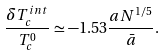Convert formula to latex. <formula><loc_0><loc_0><loc_500><loc_500>\frac { \delta T _ { c } ^ { i n t } } { T _ { c } ^ { 0 } } \simeq - 1 . 5 3 \frac { a N ^ { 1 / 5 } } { \bar { a } } .</formula> 